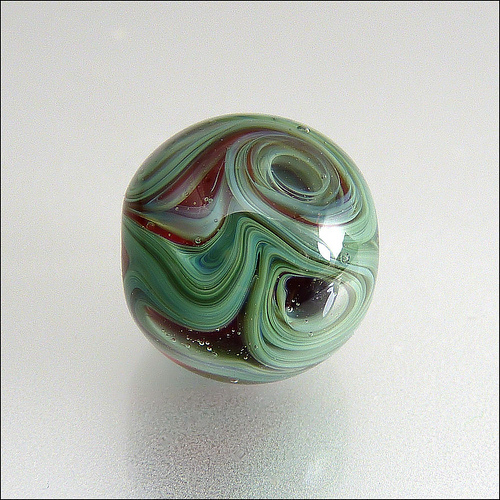<image>
Is there a swirl in front of the reflection? Yes. The swirl is positioned in front of the reflection, appearing closer to the camera viewpoint. 